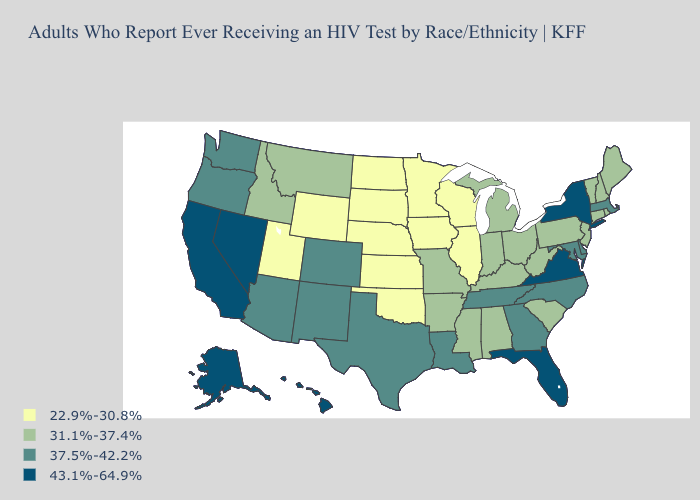What is the value of Missouri?
Give a very brief answer. 31.1%-37.4%. Name the states that have a value in the range 37.5%-42.2%?
Answer briefly. Arizona, Colorado, Delaware, Georgia, Louisiana, Maryland, Massachusetts, New Mexico, North Carolina, Oregon, Tennessee, Texas, Washington. Name the states that have a value in the range 37.5%-42.2%?
Be succinct. Arizona, Colorado, Delaware, Georgia, Louisiana, Maryland, Massachusetts, New Mexico, North Carolina, Oregon, Tennessee, Texas, Washington. Name the states that have a value in the range 22.9%-30.8%?
Answer briefly. Illinois, Iowa, Kansas, Minnesota, Nebraska, North Dakota, Oklahoma, South Dakota, Utah, Wisconsin, Wyoming. Which states hav the highest value in the South?
Be succinct. Florida, Virginia. What is the highest value in the West ?
Write a very short answer. 43.1%-64.9%. What is the value of Wyoming?
Short answer required. 22.9%-30.8%. What is the value of Nevada?
Short answer required. 43.1%-64.9%. Does Colorado have a higher value than Wyoming?
Concise answer only. Yes. What is the highest value in states that border Idaho?
Quick response, please. 43.1%-64.9%. Which states hav the highest value in the MidWest?
Keep it brief. Indiana, Michigan, Missouri, Ohio. Among the states that border California , which have the highest value?
Give a very brief answer. Nevada. Name the states that have a value in the range 37.5%-42.2%?
Quick response, please. Arizona, Colorado, Delaware, Georgia, Louisiana, Maryland, Massachusetts, New Mexico, North Carolina, Oregon, Tennessee, Texas, Washington. Does the first symbol in the legend represent the smallest category?
Keep it brief. Yes. Which states have the highest value in the USA?
Quick response, please. Alaska, California, Florida, Hawaii, Nevada, New York, Virginia. 